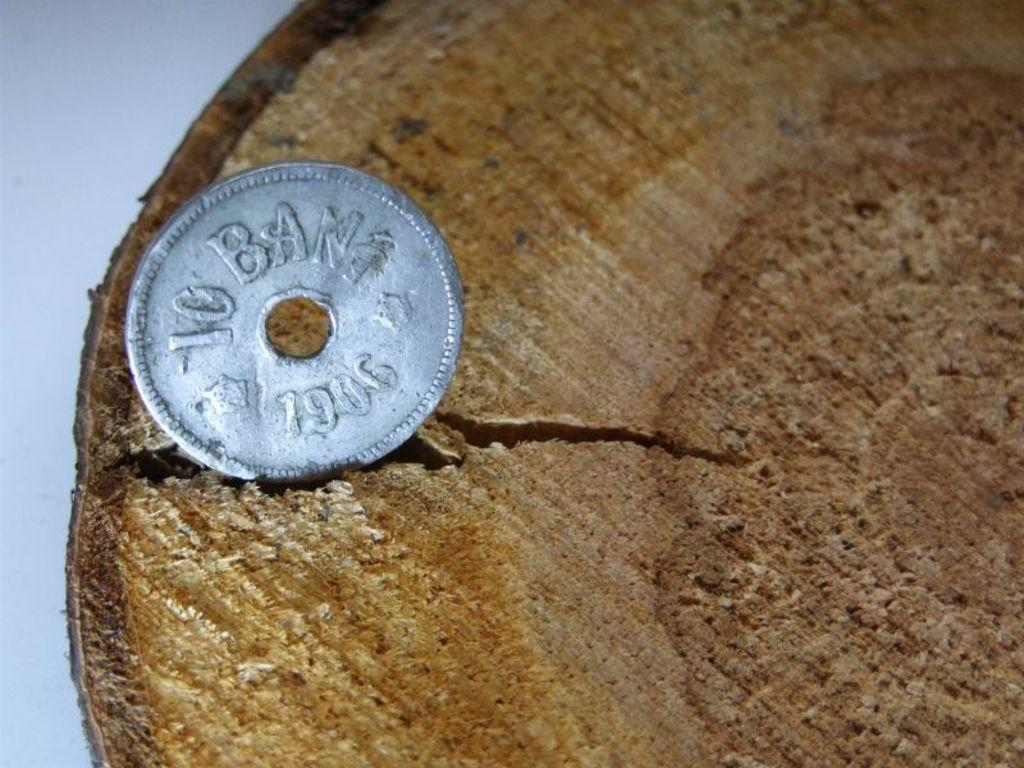Provide a one-sentence caption for the provided image. a silver coin on a wooden surface that says 10 ban 1906. 